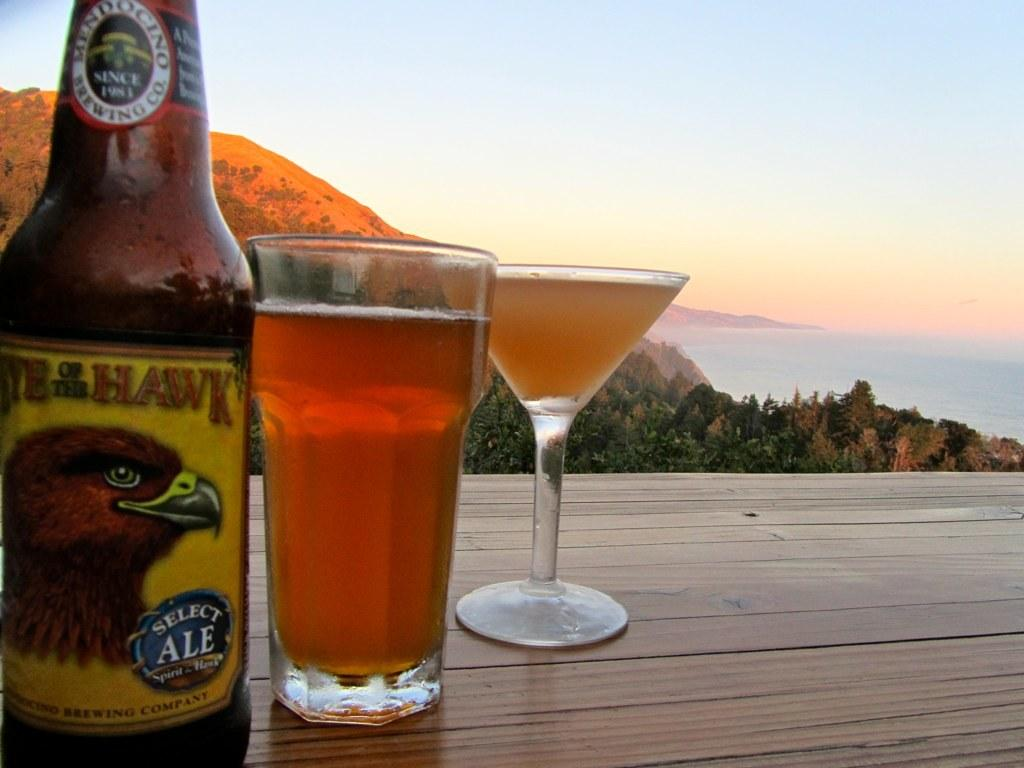How many glasses are on the table in the image? There are two glasses on the table in the image. What else is on the table besides the glasses? There is a bottle on the table. What is inside the glasses? There is liquid in the glasses. What type of vegetation can be seen in the image? There are trees with green color in the image. What geographical feature is visible in the image? There are mountains in the image. What is the color of the sky in the image? The sky is blue in color. Can you see any tanks in the image? There are no tanks present in the image. Are there any fairies flying around the trees in the image? There are no fairies present in the image. 